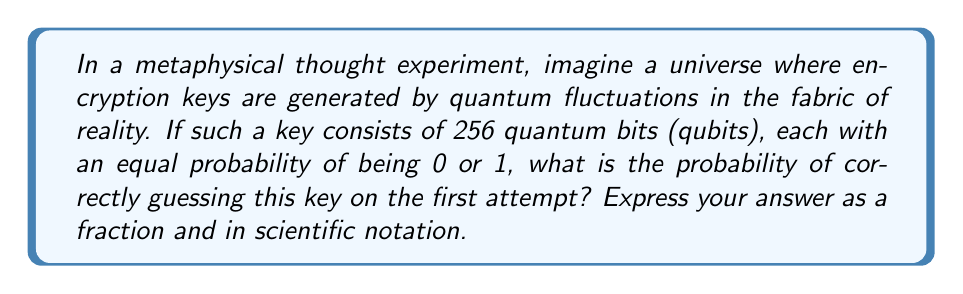Can you solve this math problem? Let's approach this step-by-step:

1) Each qubit in the key has two possible states: 0 or 1.

2) The probability of correctly guessing a single qubit is $\frac{1}{2}$.

3) For a 256-qubit key, we need to correctly guess all 256 qubits.

4) The probability of independent events occurring simultaneously is the product of their individual probabilities.

5) Therefore, the probability of guessing all 256 qubits correctly is:

   $$ P = (\frac{1}{2})^{256} $$

6) To calculate this:
   
   $$ P = \frac{1}{2^{256}} $$

7) This can be expressed as a fraction: $\frac{1}{2^{256}}$

8) To express this in scientific notation:
   
   $$ 2^{256} = 1.1579208923731619542357098500869 \times 10^{77} $$

9) Therefore, in scientific notation:
   
   $$ P = 8.636168555094445 \times 10^{-78} $$
Answer: $\frac{1}{2^{256}}$ or $8.636 \times 10^{-78}$ 